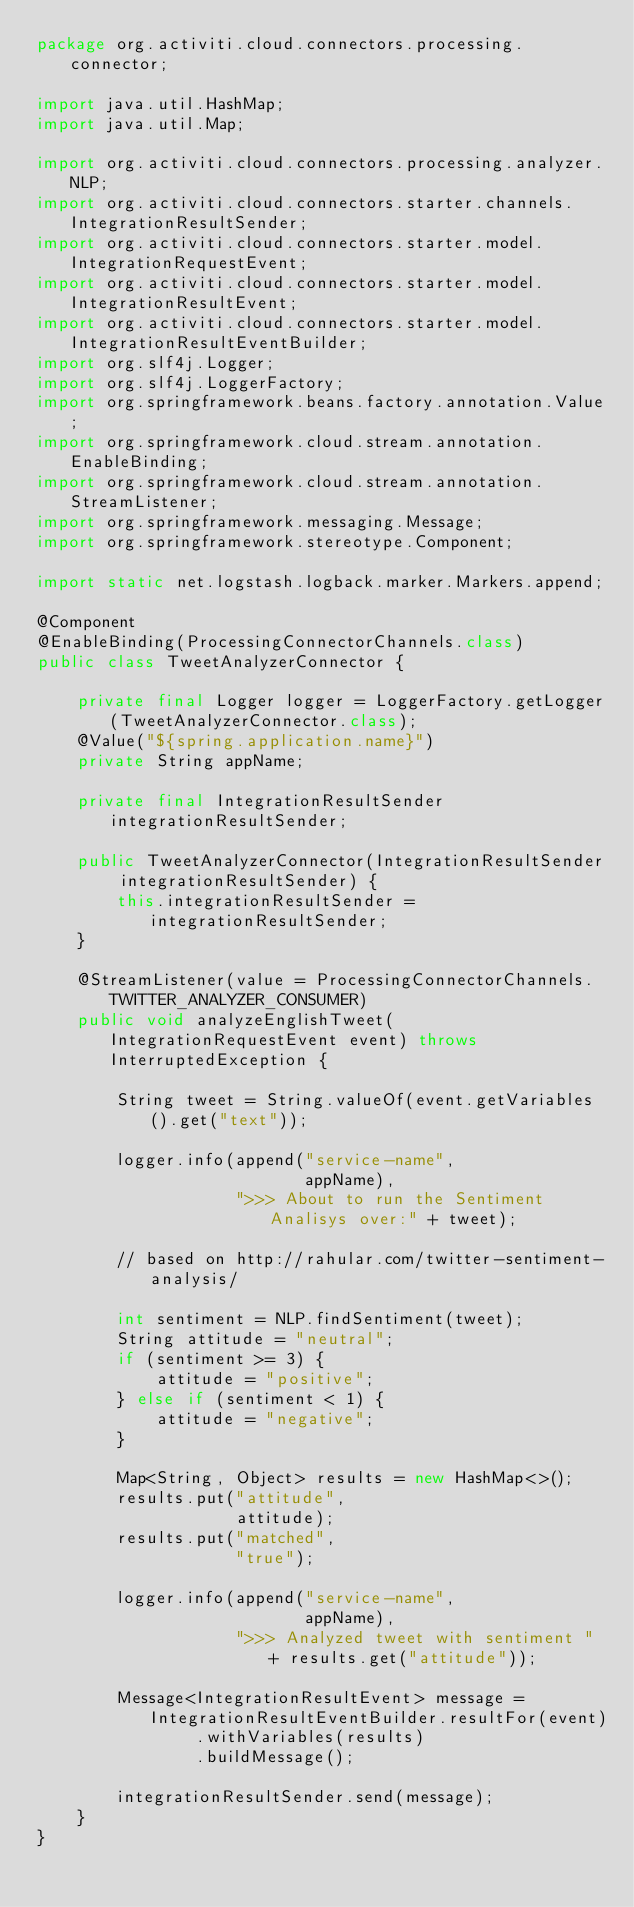Convert code to text. <code><loc_0><loc_0><loc_500><loc_500><_Java_>package org.activiti.cloud.connectors.processing.connector;

import java.util.HashMap;
import java.util.Map;

import org.activiti.cloud.connectors.processing.analyzer.NLP;
import org.activiti.cloud.connectors.starter.channels.IntegrationResultSender;
import org.activiti.cloud.connectors.starter.model.IntegrationRequestEvent;
import org.activiti.cloud.connectors.starter.model.IntegrationResultEvent;
import org.activiti.cloud.connectors.starter.model.IntegrationResultEventBuilder;
import org.slf4j.Logger;
import org.slf4j.LoggerFactory;
import org.springframework.beans.factory.annotation.Value;
import org.springframework.cloud.stream.annotation.EnableBinding;
import org.springframework.cloud.stream.annotation.StreamListener;
import org.springframework.messaging.Message;
import org.springframework.stereotype.Component;

import static net.logstash.logback.marker.Markers.append;

@Component
@EnableBinding(ProcessingConnectorChannels.class)
public class TweetAnalyzerConnector {

    private final Logger logger = LoggerFactory.getLogger(TweetAnalyzerConnector.class);
    @Value("${spring.application.name}")
    private String appName;

    private final IntegrationResultSender integrationResultSender;

    public TweetAnalyzerConnector(IntegrationResultSender integrationResultSender) {
        this.integrationResultSender = integrationResultSender;
    }

    @StreamListener(value = ProcessingConnectorChannels.TWITTER_ANALYZER_CONSUMER)
    public void analyzeEnglishTweet(IntegrationRequestEvent event) throws InterruptedException {

        String tweet = String.valueOf(event.getVariables().get("text"));

        logger.info(append("service-name",
                           appName),
                    ">>> About to run the Sentiment Analisys over:" + tweet);

        // based on http://rahular.com/twitter-sentiment-analysis/

        int sentiment = NLP.findSentiment(tweet);
        String attitude = "neutral";
        if (sentiment >= 3) {
            attitude = "positive";
        } else if (sentiment < 1) {
            attitude = "negative";
        }

        Map<String, Object> results = new HashMap<>();
        results.put("attitude",
                    attitude);
        results.put("matched",
                    "true");

        logger.info(append("service-name",
                           appName),
                    ">>> Analyzed tweet with sentiment " + results.get("attitude"));

        Message<IntegrationResultEvent> message = IntegrationResultEventBuilder.resultFor(event)
                .withVariables(results)
                .buildMessage();

        integrationResultSender.send(message);
    }
}
</code> 